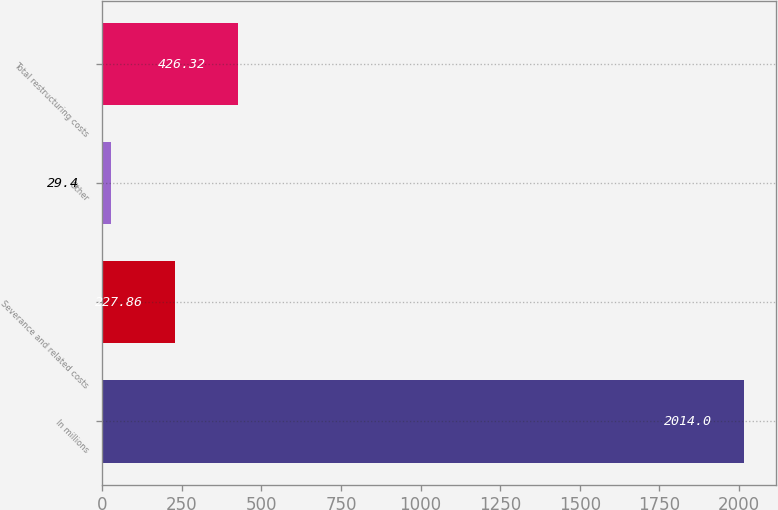Convert chart to OTSL. <chart><loc_0><loc_0><loc_500><loc_500><bar_chart><fcel>In millions<fcel>Severance and related costs<fcel>Other<fcel>Total restructuring costs<nl><fcel>2014<fcel>227.86<fcel>29.4<fcel>426.32<nl></chart> 